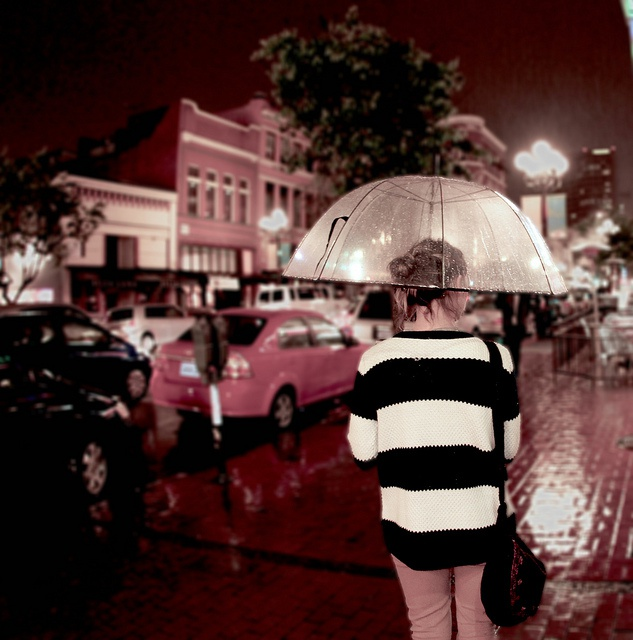Describe the objects in this image and their specific colors. I can see people in black, beige, brown, and maroon tones, umbrella in black, lightgray, darkgray, and tan tones, car in black, maroon, brown, and gray tones, car in black, brown, and maroon tones, and car in black, brown, and maroon tones in this image. 